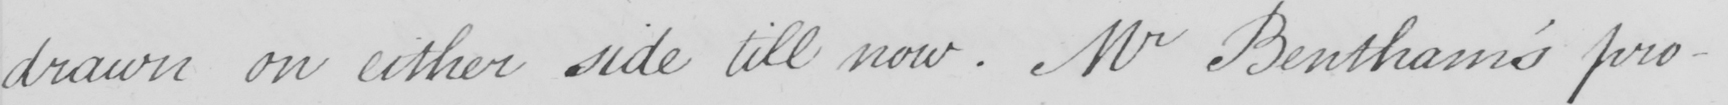What is written in this line of handwriting? drawn on either side till now . Mr Bentham ' s pro- 